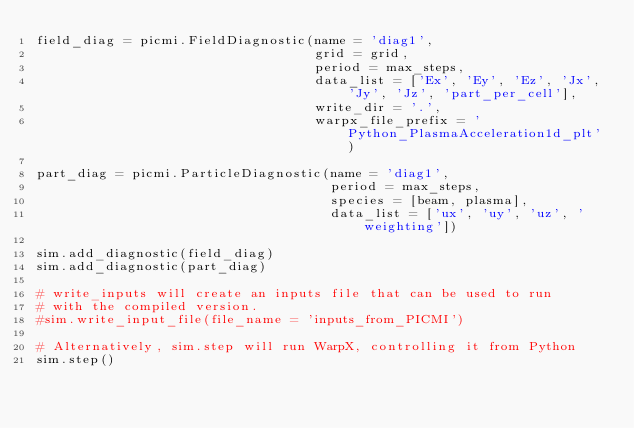<code> <loc_0><loc_0><loc_500><loc_500><_Python_>field_diag = picmi.FieldDiagnostic(name = 'diag1',
                                   grid = grid,
                                   period = max_steps,
                                   data_list = ['Ex', 'Ey', 'Ez', 'Jx', 'Jy', 'Jz', 'part_per_cell'],
                                   write_dir = '.',
                                   warpx_file_prefix = 'Python_PlasmaAcceleration1d_plt')

part_diag = picmi.ParticleDiagnostic(name = 'diag1',
                                     period = max_steps,
                                     species = [beam, plasma],
                                     data_list = ['ux', 'uy', 'uz', 'weighting'])

sim.add_diagnostic(field_diag)
sim.add_diagnostic(part_diag)

# write_inputs will create an inputs file that can be used to run
# with the compiled version.
#sim.write_input_file(file_name = 'inputs_from_PICMI')

# Alternatively, sim.step will run WarpX, controlling it from Python
sim.step()
</code> 